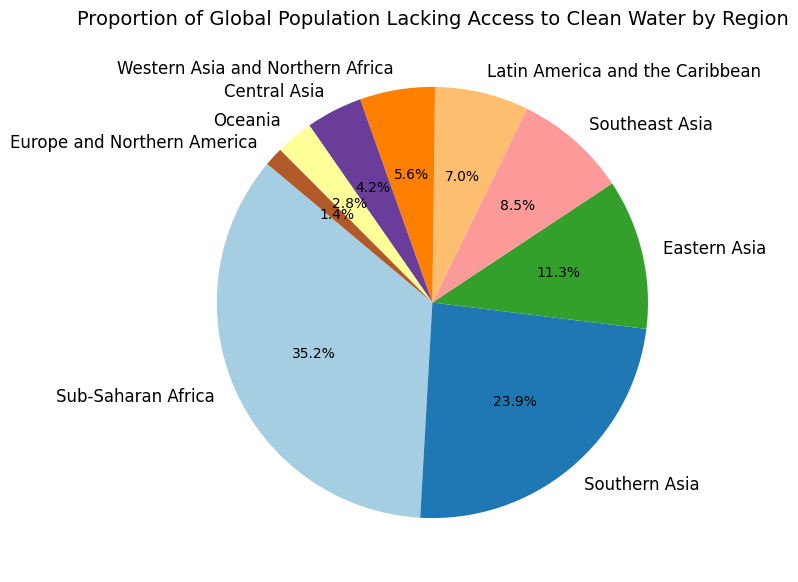What region has the highest proportion of the global population lacking access to clean water? Observing the slices of the pie chart, the largest portion belongs to Sub-Saharan Africa.
Answer: Sub-Saharan Africa What is the combined proportion of the global population lacking access to clean water in Southern Asia and Eastern Asia? Add the proportions of Southern Asia (17%) and Eastern Asia (8%). 17% + 8% = 25%.
Answer: 25% How does the proportion of the global population lacking access to clean water in Oceania compare to that in Europe and Northern America? Compare the slices of both regions: Oceania accounts for 2%, and Europe and Northern America for 1%. 2% is greater than 1%.
Answer: Oceania has a higher proportion Which regions have a proportion of the global population lacking access to clean water that is less than 5%? Check all regions with portions smaller than 5%: Western Asia and Northern Africa (4%), Central Asia (3%), Oceania (2%), and Europe and Northern America (1%).
Answer: Western Asia and Northern Africa, Central Asia, Oceania, Europe and Northern America What is the total proportion of the global population lacking access to clean water in Sub-Saharan Africa, Southern Asia, and Southeast Asia combined? Sum the proportions of Sub-Saharan Africa (25%), Southern Asia (17%), and Southeast Asia (6%): 25% + 17% + 6% = 48%.
Answer: 48% What proportion of the global population lacking access to clean water is represented by Western Asia and Northern Africa? Look at the corresponding slice in the pie chart. The figure shows Western Asia and Northern Africa at 4%.
Answer: 4% Is the proportion of the global population lacking access to clean water in Latin America and the Caribbean higher than that in Central Asia? Compare the proportions of Latin America and the Caribbean (5%) and Central Asia (3%). 5% is higher than 3%.
Answer: Yes Which region has the smallest proportion of the global population lacking access to clean water? Identify the region with the smallest slice in the pie chart. It is Europe and Northern America at 1%.
Answer: Europe and Northern America What is the difference in the proportions of the global population lacking access to clean water between Sub-Saharan Africa and Eastern Asia? Subtract the proportion of Eastern Asia (8%) from Sub-Saharan Africa (25%): 25% - 8% = 17%.
Answer: 17% What regions have a proportion between 5% and 10% of the global population lacking access to clean water? Identify the regions within the specified range: Eastern Asia (8%) and Southeast Asia (6%).
Answer: Eastern Asia, Southeast Asia 